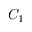Convert formula to latex. <formula><loc_0><loc_0><loc_500><loc_500>C _ { 1 }</formula> 